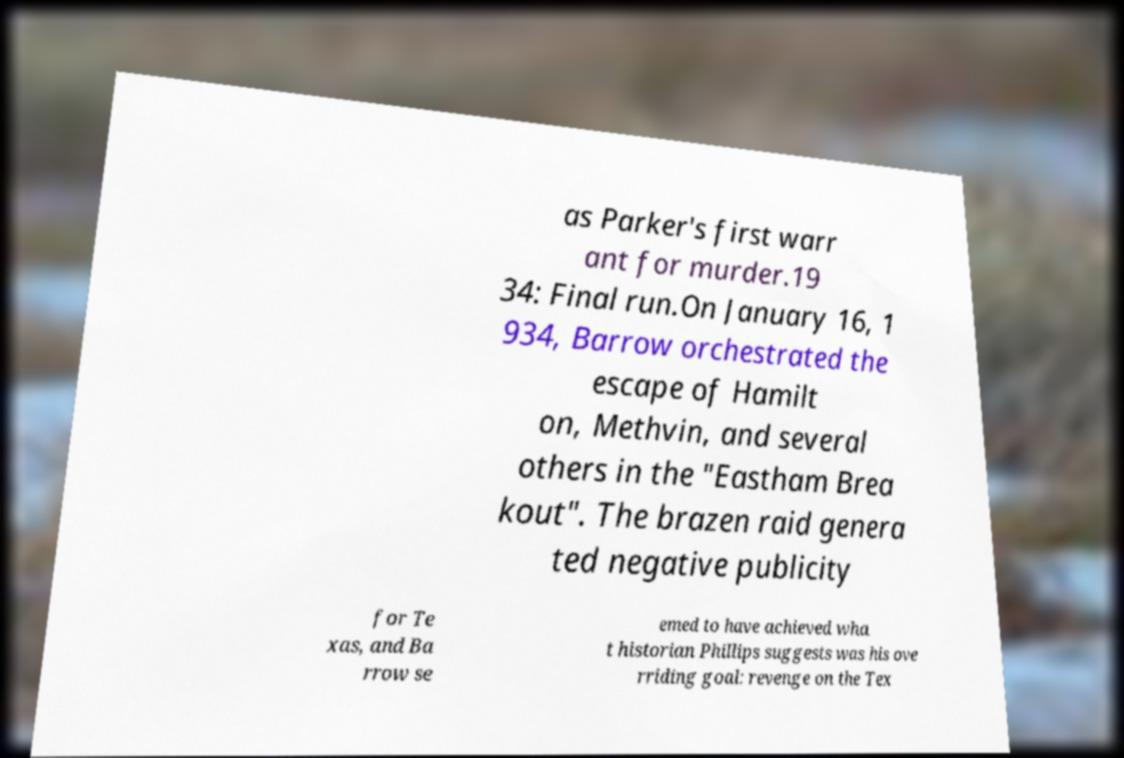Can you accurately transcribe the text from the provided image for me? as Parker's first warr ant for murder.19 34: Final run.On January 16, 1 934, Barrow orchestrated the escape of Hamilt on, Methvin, and several others in the "Eastham Brea kout". The brazen raid genera ted negative publicity for Te xas, and Ba rrow se emed to have achieved wha t historian Phillips suggests was his ove rriding goal: revenge on the Tex 